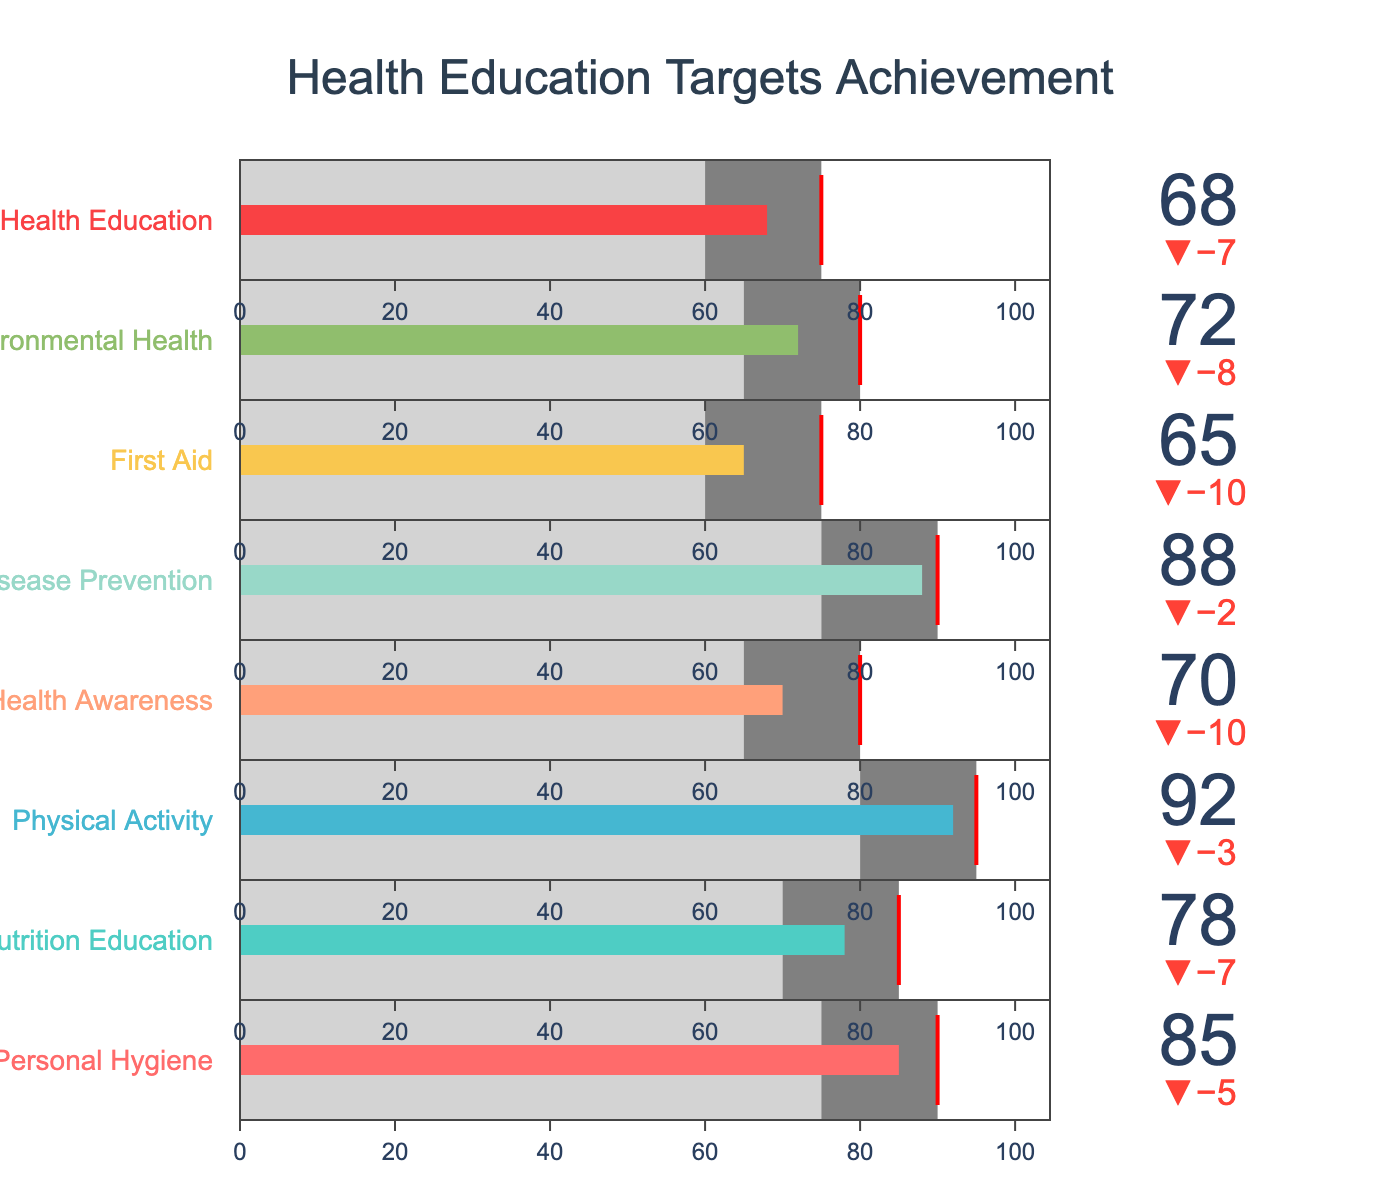What is the title of the chart? The title is generally displayed at the top of the chart, in this case, it reads "Health Education Targets Achievement".
Answer: Health Education Targets Achievement Which subject area has the highest actual achievement value? The highest actual achievement value can be identified as the tallest bar on the chart. In this case, it is for "Physical Activity" with a value of 92.
Answer: Physical Activity Are there any subjects where the actual achievement exceeds the target? If yes, which ones? To determine if the actual achievement exceeds the target, we look for values where the indicator's bar exceeds their target mark (red line). There are no subjects where the actual achievement exceeds the target.
Answer: None What subject has the lowest actual achievement value and what is it? The lowest actual achievement value is represented by the shortest bar on the chart, which belongs to "First Aid" with a value of 65.
Answer: First Aid, 65 How many subjects have an actual achievement value that is at least 10 points below the target? To find this, we compare each actual achievement value with its respective target minus 10 points. The subjects are "First Aid" (65 < 75-10), "Mental Health Awareness" (70 < 80-10), "Sexual Health Education" (68 < 75-10). There are 3 subjects.
Answer: 3 subjects Which subject is closest to meeting its target and what is the difference between the actual and target value? The closest can be found by subtracting the target value from the actual value and looking for the smallest positive number. For "Personal Hygiene" (85-90=-5), "Nutrition Education" (78-85=-7), "Physical Activity" (92-95=-3), "Mental Health Awareness" (70-80=-10), "Disease Prevention" (88-90=-2), "First Aid" (65-75=-10), "Environmental Health" (72-80=-8), "Sexual Health Education" (68-75=-7). The closest is "Disease Prevention" with a difference of 2 points.
Answer: Disease Prevention, 2 points Which two subject areas have the highest difference between the actual achievement and benchmark? Calculating the difference, "Personal Hygiene" (85-75=10), "Nutrition Education" (78-70=8), "Physical Activity" (92-80=12), "Mental Health Awareness" (70-65=5), "Disease Prevention" (88-75=13), "First Aid" (65-60=5), "Environmental Health" (72-65=7), "Sexual Health Education" (68-60=8). The highest differences are "Disease Prevention" (13) and "Physical Activity" (12).
Answer: Disease Prevention, Physical Activity Which subjects achieved above the benchmark but fell short of their target? We look for subjects where the actual value is greater than the benchmark but less than the target: "Personal Hygiene" (85 > 75 and 85 < 90), "Nutrition Education" (78 > 70 and 78 < 85), "Physical Activity" (92 > 80 and 92 < 95), "Mental Health Awareness" (70 > 65, 70 < 80), "Disease Prevention" (88 > 75 and 88 < 90), "Environmental Health" (72 > 65 and 72 < 80), "Sexual Health Education" (68 > 60 and 68 < 75). These subjects are "Personal Hygiene", "Nutrition Education", "Physical Activity", "Mental Health Awareness", "Disease Prevention", "Environmental Health", and "Sexual Health Education".
Answer: 7 subjects What is the average target value for all subject areas? Sum all target values and divide by the total number of subjects: (90+85+95+80+90+75+80+75) = 670; Number of subjects = 8; So, the average is 670/8 = 83.75
Answer: 83.75 